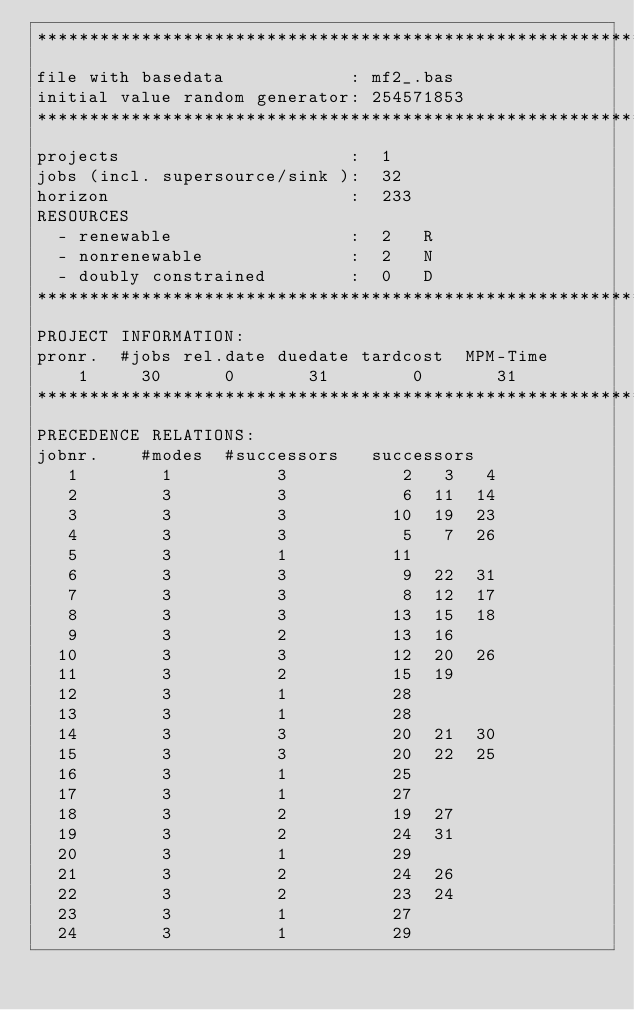<code> <loc_0><loc_0><loc_500><loc_500><_ObjectiveC_>************************************************************************
file with basedata            : mf2_.bas
initial value random generator: 254571853
************************************************************************
projects                      :  1
jobs (incl. supersource/sink ):  32
horizon                       :  233
RESOURCES
  - renewable                 :  2   R
  - nonrenewable              :  2   N
  - doubly constrained        :  0   D
************************************************************************
PROJECT INFORMATION:
pronr.  #jobs rel.date duedate tardcost  MPM-Time
    1     30      0       31        0       31
************************************************************************
PRECEDENCE RELATIONS:
jobnr.    #modes  #successors   successors
   1        1          3           2   3   4
   2        3          3           6  11  14
   3        3          3          10  19  23
   4        3          3           5   7  26
   5        3          1          11
   6        3          3           9  22  31
   7        3          3           8  12  17
   8        3          3          13  15  18
   9        3          2          13  16
  10        3          3          12  20  26
  11        3          2          15  19
  12        3          1          28
  13        3          1          28
  14        3          3          20  21  30
  15        3          3          20  22  25
  16        3          1          25
  17        3          1          27
  18        3          2          19  27
  19        3          2          24  31
  20        3          1          29
  21        3          2          24  26
  22        3          2          23  24
  23        3          1          27
  24        3          1          29</code> 